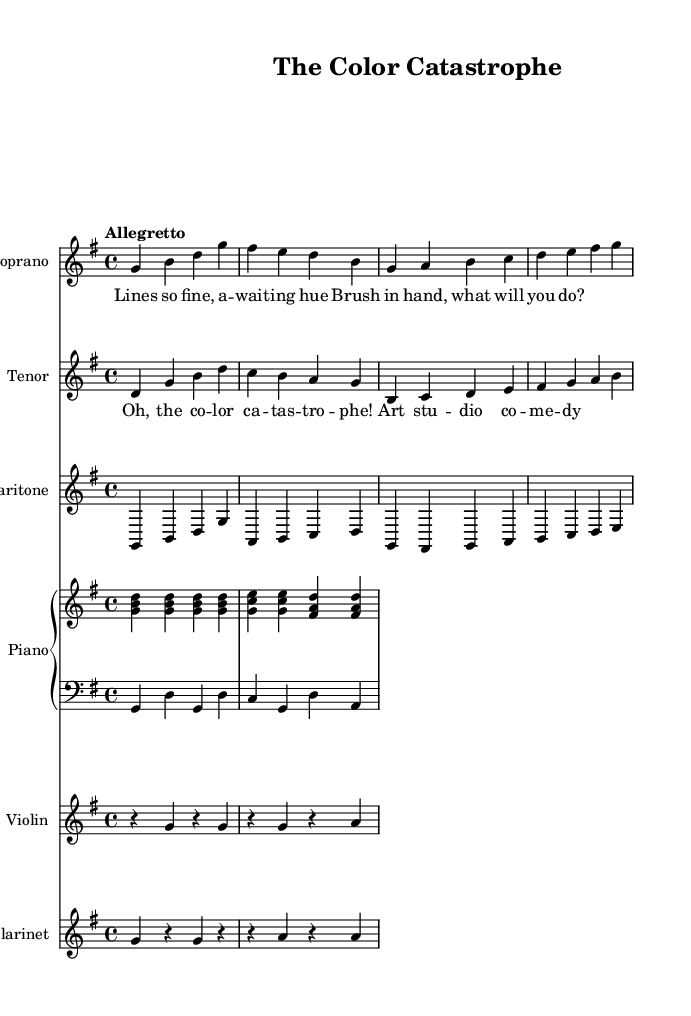What is the key signature of this music? The key signature shows one sharp, which indicates that the music is in G major, as G major has one sharp (F sharp).
Answer: G major What is the time signature of this music? The time signature is indicated at the beginning of the score, showing a 4 over 4, meaning there are four beats per measure with a quarter note receiving one beat.
Answer: 4/4 What is the tempo marking for this piece? The tempo marking is written at the beginning of the score as "Allegretto," which indicates a moderately fast tempo.
Answer: Allegretto How many vocal parts are present in this opera? By examining the score, there are three distinct vocal parts shown: soprano, tenor, and baritone, indicating a total of three vocal parts.
Answer: Three What is the main theme expressed in the lyrics of the soprano part? The lyrics in the soprano part express a struggle with the color and choices in art, hinting at a sense of anticipation and decision-making regarding colors.
Answer: Anticipation Which instruments are included in the orchestration of this piece? The orchestration includes a piano (with both upper and lower staves), a violin, and a clarinet, making a total of four different instruments.
Answer: Four What do the repeated musical phrases in the soprano and tenor parts signify in the opera's narrative? The repeated phrases in the soprano and tenor parts emphasize the emotional turmoil and comedic elements of the artistic struggles depicted, indicating moments of reflection or conflict in the storyline.
Answer: Emotional turmoil 